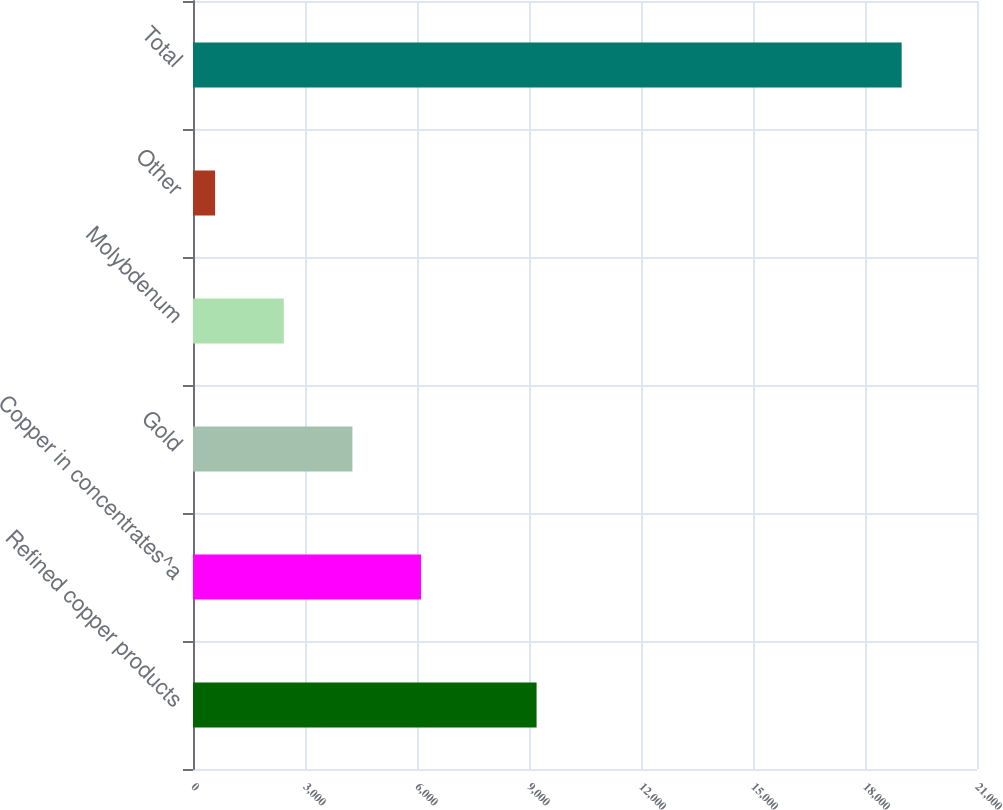<chart> <loc_0><loc_0><loc_500><loc_500><bar_chart><fcel>Refined copper products<fcel>Copper in concentrates^a<fcel>Gold<fcel>Molybdenum<fcel>Other<fcel>Total<nl><fcel>9203<fcel>6109<fcel>4270<fcel>2431<fcel>592<fcel>18982<nl></chart> 